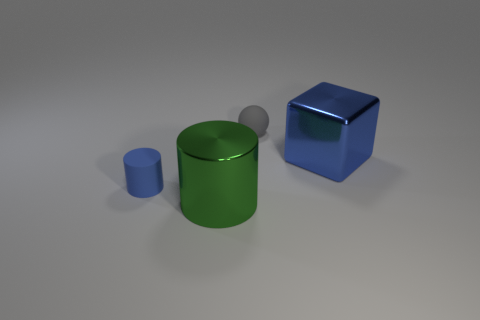Add 4 big matte balls. How many objects exist? 8 Subtract all cubes. How many objects are left? 3 Subtract 1 blue cylinders. How many objects are left? 3 Subtract all green objects. Subtract all rubber cylinders. How many objects are left? 2 Add 3 large blue metal objects. How many large blue metal objects are left? 4 Add 4 large metal cylinders. How many large metal cylinders exist? 5 